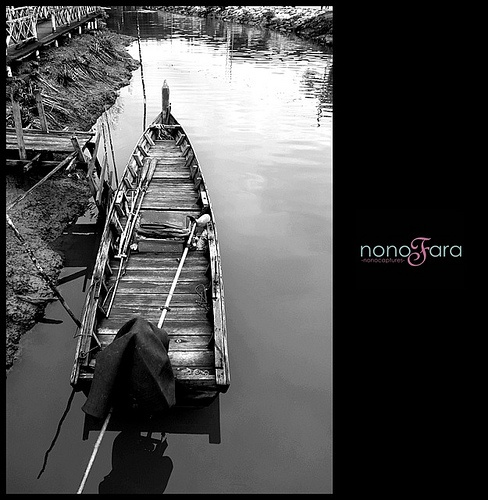Describe the objects in this image and their specific colors. I can see a boat in black, gray, darkgray, and lightgray tones in this image. 